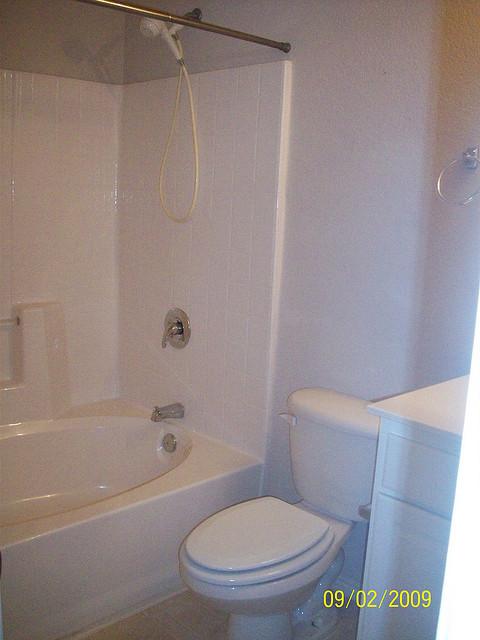Is the toilet seat open?
Short answer required. No. What room is this?
Keep it brief. Bathroom. Is there a shower curtain?
Concise answer only. No. Is this a designer bathroom?
Concise answer only. No. How many metallic objects are shown?
Quick response, please. 4. Does this bathroom stink?
Keep it brief. No. Is the room lit by sunlight?
Give a very brief answer. Yes. Is there a mirror in the room?
Keep it brief. No. Is this bathroom all white?
Concise answer only. Yes. Is there a pattern in this room?
Short answer required. No. What is on the shower walls?
Answer briefly. Tile. What is the date on the calendar in the photo?
Short answer required. 09/02/2009. Does this bathroom look clean?
Concise answer only. Yes. Is this designed for handicap individuals?
Write a very short answer. No. 